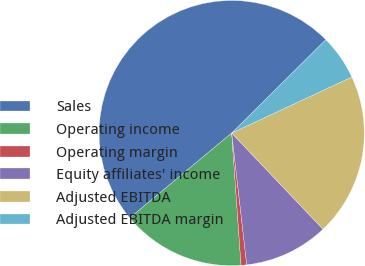Convert chart to OTSL. <chart><loc_0><loc_0><loc_500><loc_500><pie_chart><fcel>Sales<fcel>Operating income<fcel>Operating margin<fcel>Equity affiliates' income<fcel>Adjusted EBITDA<fcel>Adjusted EBITDA margin<nl><fcel>48.62%<fcel>15.07%<fcel>0.69%<fcel>10.28%<fcel>19.86%<fcel>5.48%<nl></chart> 